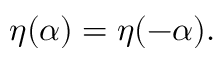<formula> <loc_0><loc_0><loc_500><loc_500>\eta ( \alpha ) = \eta ( - \alpha ) .</formula> 